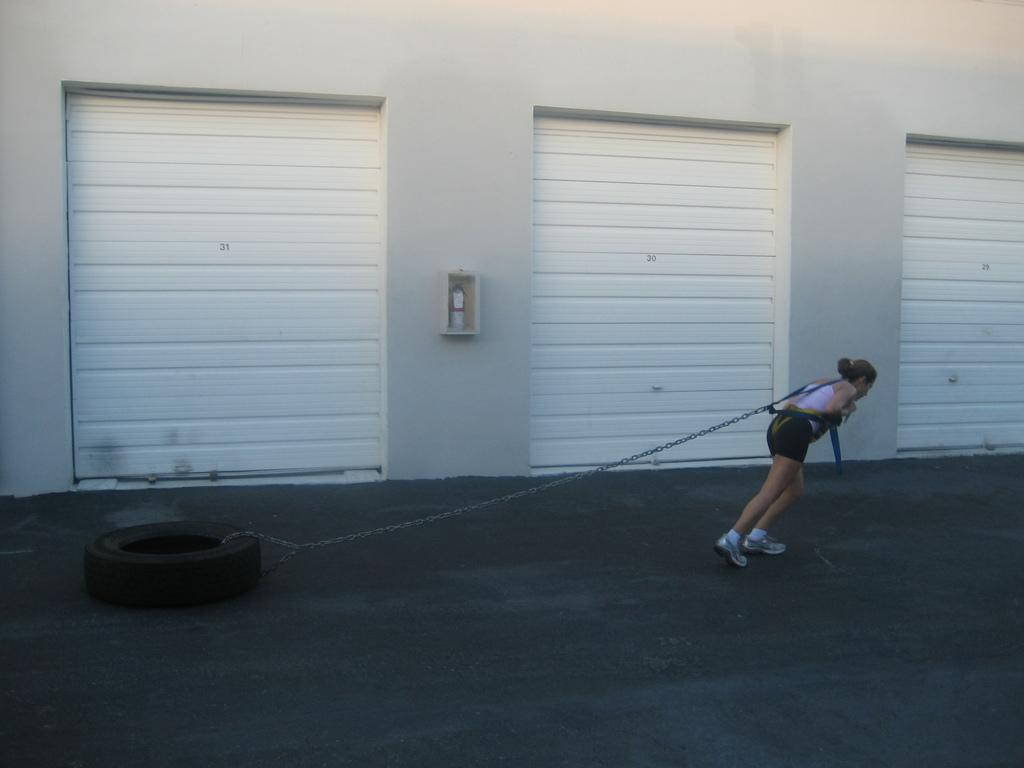Who is the main subject in the image? There is a woman in the image. What is the woman doing in the image? The woman is trying to pull a tyre. What tool is the woman using to pull the tyre? The woman is using a metal chain to pull the tyre. What architectural feature can be seen in the image? There are shutters visible in the image. What type of cloth is the woman using to pull the tyre? The woman is not using a cloth to pull the tyre; she is using a metal chain. 